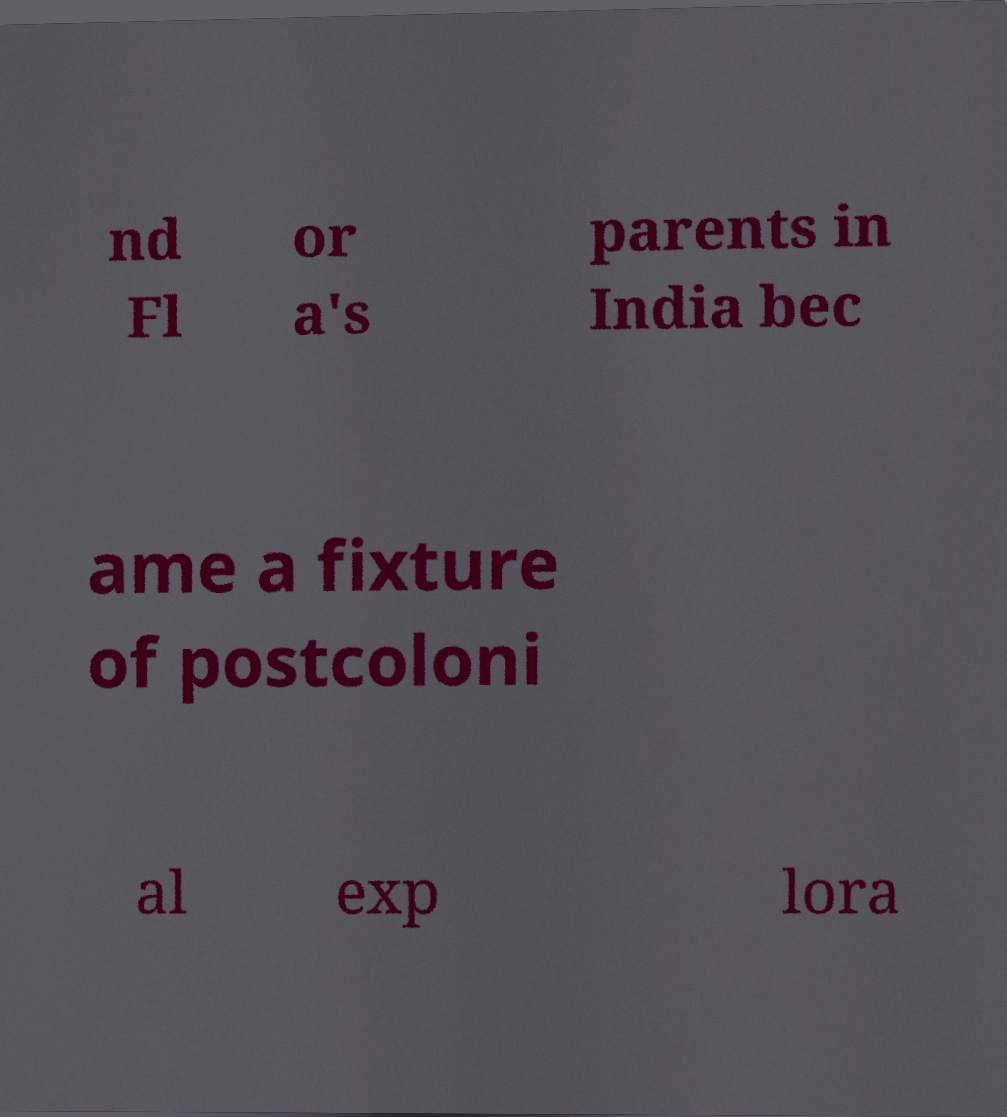There's text embedded in this image that I need extracted. Can you transcribe it verbatim? nd Fl or a's parents in India bec ame a fixture of postcoloni al exp lora 